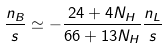Convert formula to latex. <formula><loc_0><loc_0><loc_500><loc_500>\frac { n _ { B } } { s } \simeq - \frac { 2 4 + 4 N _ { H } } { 6 6 + 1 3 N _ { H } } \frac { n _ { L } } { s }</formula> 